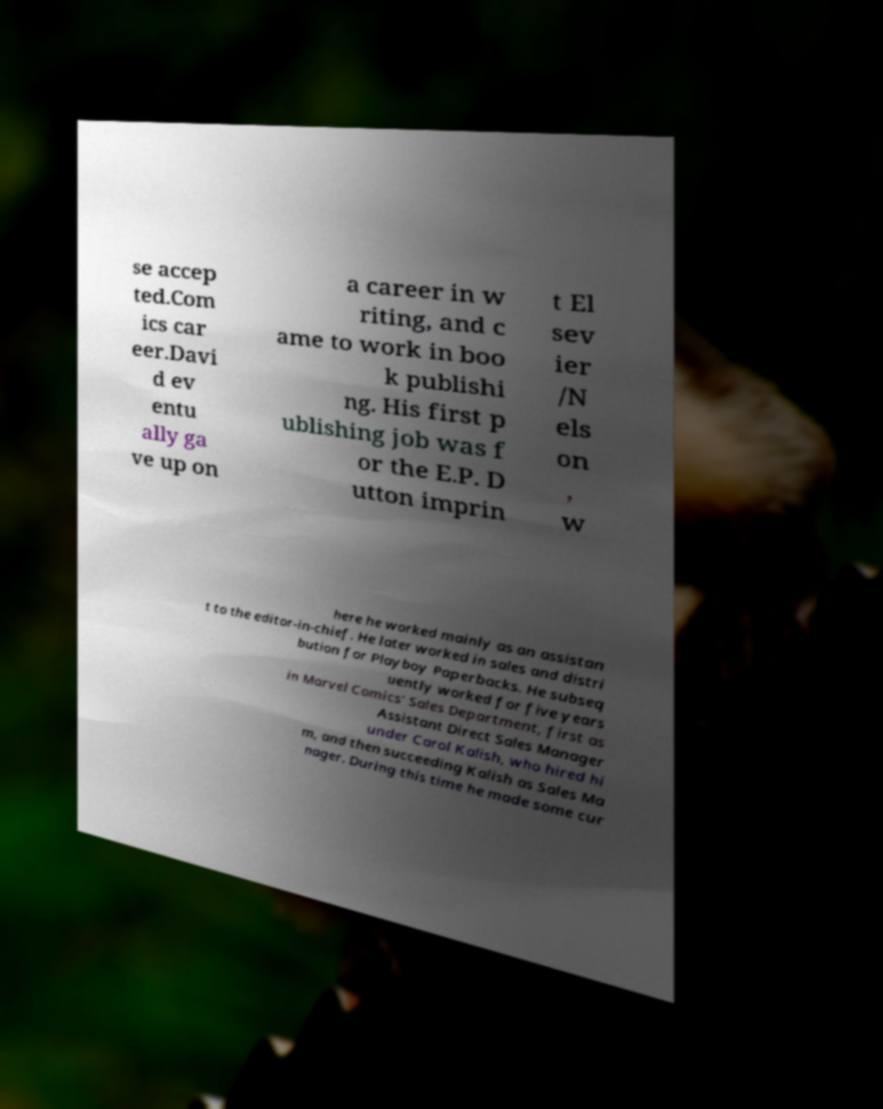Please identify and transcribe the text found in this image. se accep ted.Com ics car eer.Davi d ev entu ally ga ve up on a career in w riting, and c ame to work in boo k publishi ng. His first p ublishing job was f or the E.P. D utton imprin t El sev ier /N els on , w here he worked mainly as an assistan t to the editor-in-chief. He later worked in sales and distri bution for Playboy Paperbacks. He subseq uently worked for five years in Marvel Comics' Sales Department, first as Assistant Direct Sales Manager under Carol Kalish, who hired hi m, and then succeeding Kalish as Sales Ma nager. During this time he made some cur 